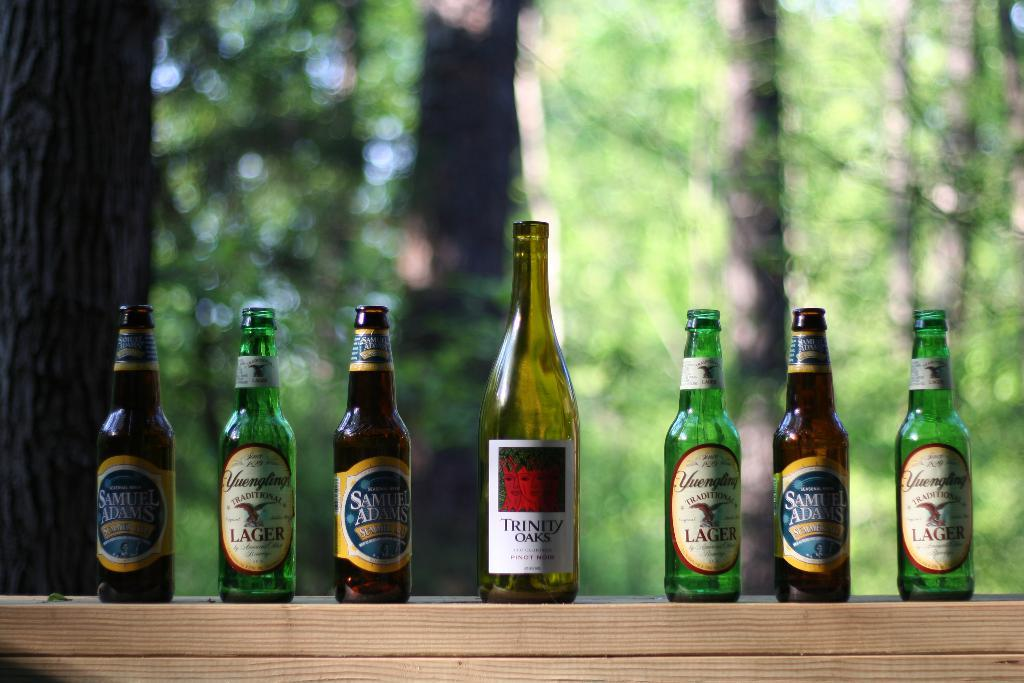<image>
Create a compact narrative representing the image presented. A bottle with the brand Trinity Oaks on the label is surrounded by other bottles. 